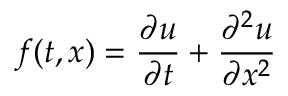<formula> <loc_0><loc_0><loc_500><loc_500>f ( t , x ) = \frac { \partial u } { \partial t } + \frac { \partial ^ { 2 } u } { \partial x ^ { 2 } }</formula> 